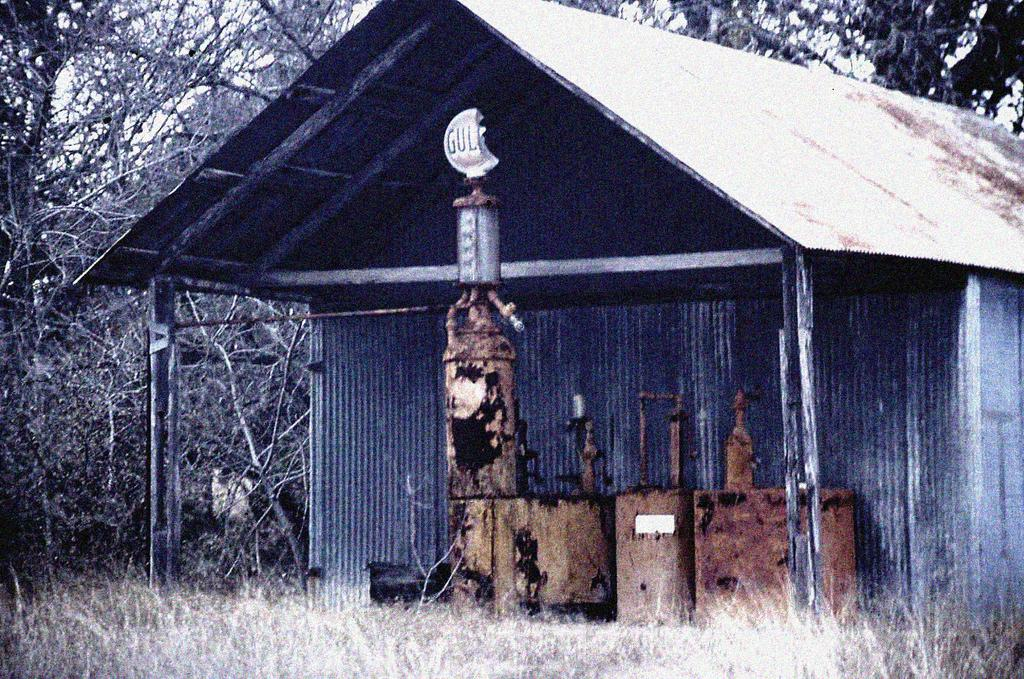What type of structure is visible in the image? There is a shed in the image. What else can be seen in the image besides the shed? There is an object that looks like a machine in the image. What type of vegetation is present in the image? Grass is present in the image. Are there any other natural elements visible in the image? Yes, there are trees in the image. How many boys are playing with the discovery in the image? There is no mention of a discovery or boys in the image; it features a shed, a machine-like object, grass, and trees. 